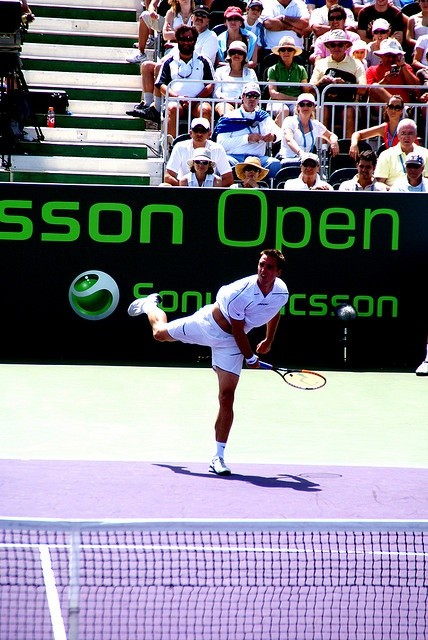Describe the objects in this image and their specific colors. I can see people in pink, black, white, maroon, and brown tones, people in pink, lightblue, white, black, and maroon tones, people in pink, lavender, black, lightblue, and maroon tones, people in pink, white, navy, lightblue, and lavender tones, and bench in pink, white, black, and darkgray tones in this image. 